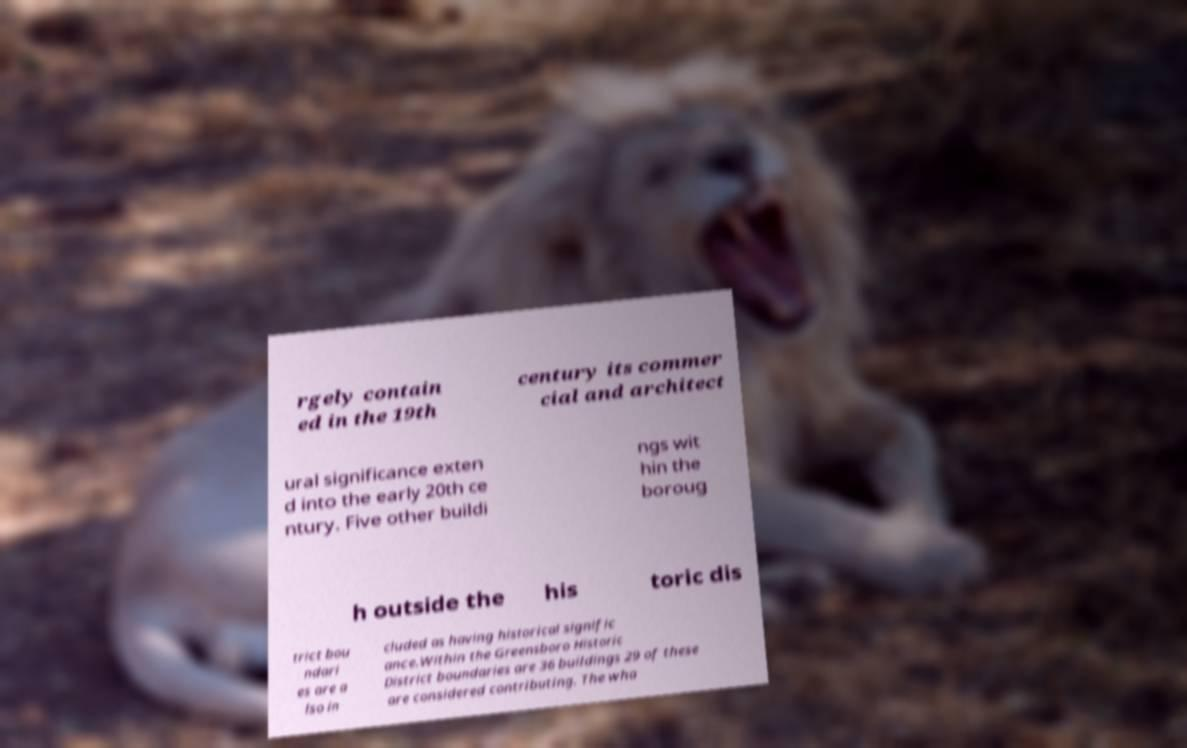For documentation purposes, I need the text within this image transcribed. Could you provide that? rgely contain ed in the 19th century its commer cial and architect ural significance exten d into the early 20th ce ntury. Five other buildi ngs wit hin the boroug h outside the his toric dis trict bou ndari es are a lso in cluded as having historical signific ance.Within the Greensboro Historic District boundaries are 36 buildings 29 of these are considered contributing. The wha 